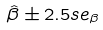<formula> <loc_0><loc_0><loc_500><loc_500>\hat { \beta } \pm 2 . 5 s e _ { \beta }</formula> 